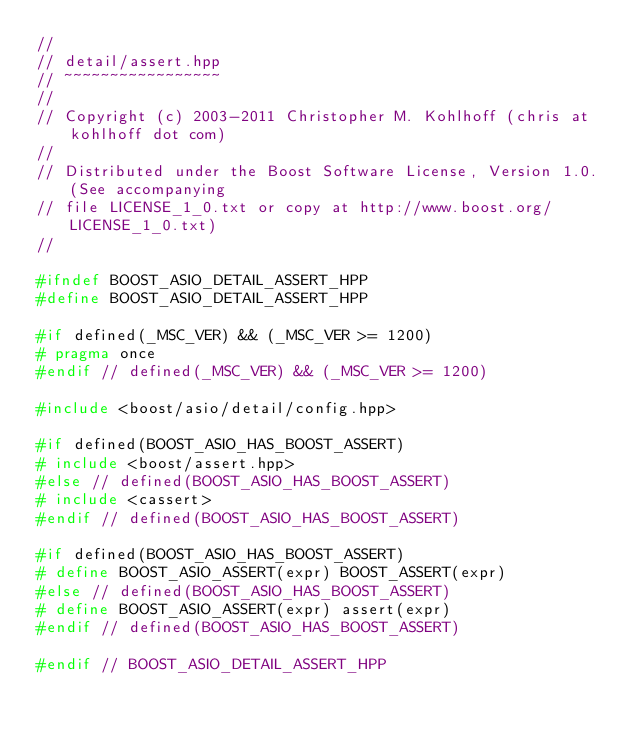<code> <loc_0><loc_0><loc_500><loc_500><_C++_>//
// detail/assert.hpp
// ~~~~~~~~~~~~~~~~~
//
// Copyright (c) 2003-2011 Christopher M. Kohlhoff (chris at kohlhoff dot com)
//
// Distributed under the Boost Software License, Version 1.0. (See accompanying
// file LICENSE_1_0.txt or copy at http://www.boost.org/LICENSE_1_0.txt)
//

#ifndef BOOST_ASIO_DETAIL_ASSERT_HPP
#define BOOST_ASIO_DETAIL_ASSERT_HPP

#if defined(_MSC_VER) && (_MSC_VER >= 1200)
# pragma once
#endif // defined(_MSC_VER) && (_MSC_VER >= 1200)

#include <boost/asio/detail/config.hpp>

#if defined(BOOST_ASIO_HAS_BOOST_ASSERT)
# include <boost/assert.hpp>
#else // defined(BOOST_ASIO_HAS_BOOST_ASSERT)
# include <cassert>
#endif // defined(BOOST_ASIO_HAS_BOOST_ASSERT)

#if defined(BOOST_ASIO_HAS_BOOST_ASSERT)
# define BOOST_ASIO_ASSERT(expr) BOOST_ASSERT(expr)
#else // defined(BOOST_ASIO_HAS_BOOST_ASSERT)
# define BOOST_ASIO_ASSERT(expr) assert(expr)
#endif // defined(BOOST_ASIO_HAS_BOOST_ASSERT)

#endif // BOOST_ASIO_DETAIL_ASSERT_HPP
</code> 